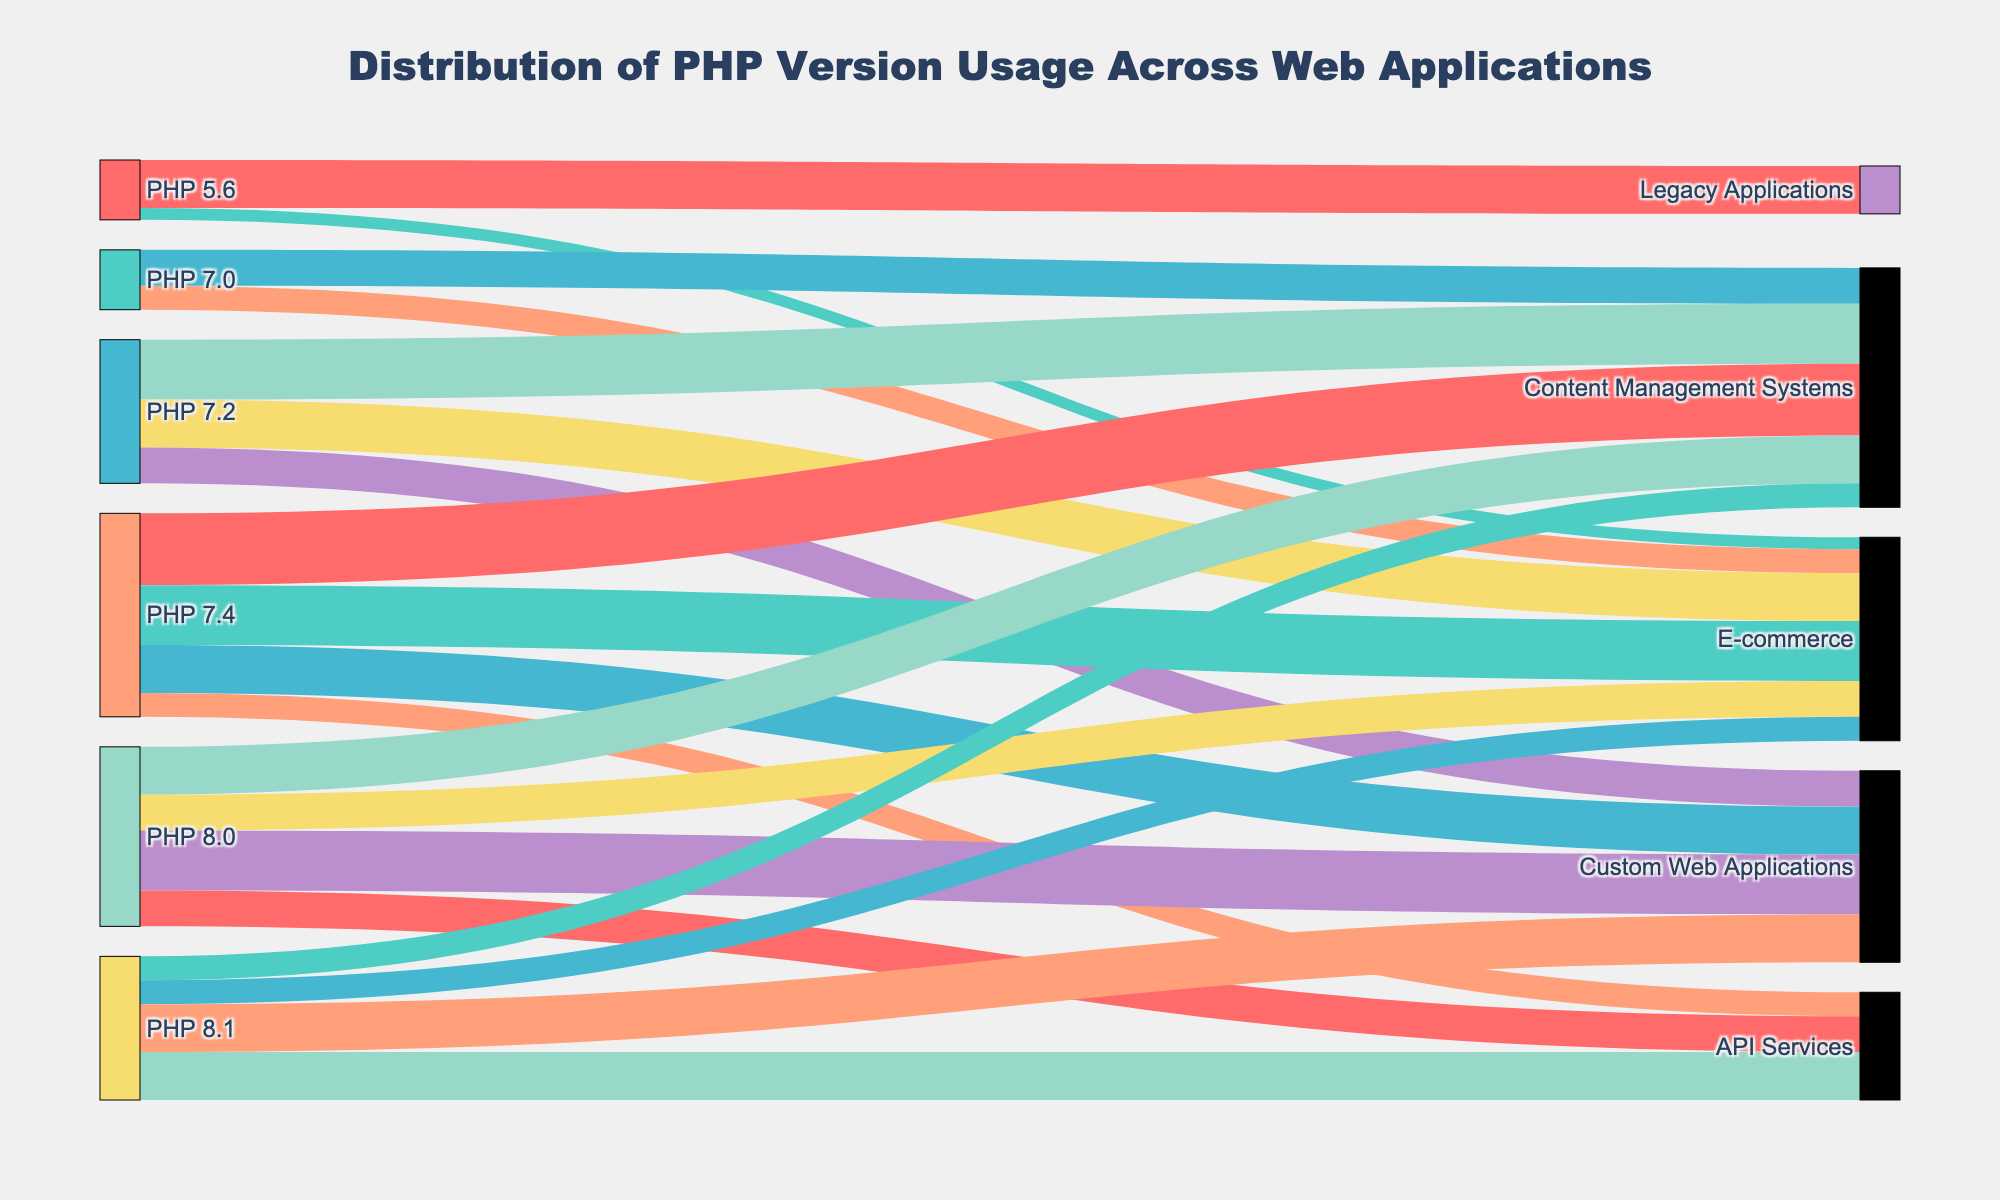What's the title of the chart? The title of the chart is displayed prominently at the top and reads "Distribution of PHP Version Usage Across Web Applications."
Answer: Distribution of PHP Version Usage Across Web Applications Which PHP version supports the highest number of different types of web applications? By observing the number of unique target nodes connected to each source, PHP 7.4 supports the most types of web applications: Content Management Systems, E-commerce, Custom Web Applications, and API Services.
Answer: PHP 7.4 What's the total number of applications using PHP 8.0? The values for PHP 8.0 are Content Management Systems (20), E-commerce (15), Custom Web Applications (25), and API Services (15). Summing these gives 20 + 15 + 25 + 15 = 75.
Answer: 75 Which type of application has the highest usage across all PHP versions? By checking the cumulative values on the target nodes, Content Management Systems accumulate the highest usage. Adding the respective values results in 15 + 25 + 30 + 20 + 10 = 100.
Answer: Content Management Systems How many more applications use PHP 7.4 for E-commerce than PHP 8.0 for E-commerce? The values for PHP 7.4 and PHP 8.0 for E-commerce are 25 and 15, respectively. The difference is 25 - 15 = 10.
Answer: 10 more applications What percentage of Legacy Applications use PHP 5.6? The total number of Legacy Applications is the value for PHP 5.6, which is 20. Since there are no other PHP versions listed for Legacy Applications, the percentage is 100%.
Answer: 100% Which PHP version is most used for Custom Web Applications? Comparing the values for Custom Web Applications, the highest value belongs to PHP 8.0 at 25.
Answer: PHP 8.0 Which PHP version is used by the least number of applications overall? By summing all the values per PHP version, PHP 5.6 has 20 + 5 = 25, which is the lowest total when compared to other PHP versions.
Answer: PHP 5.6 How does the usage of PHP 8.1 for API Services compare to its usage for Custom Web Applications? PHP 8.1 has equal values for both API Services (20) and Custom Web Applications (20), indicating the usage is the same.
Answer: Equal What's the combined total usage of PHP 7.2 and PHP 7.4 for E-commerce applications? Summing the values for PHP 7.2 (20) and PHP 7.4 (25) results in 20 + 25 = 45.
Answer: 45 